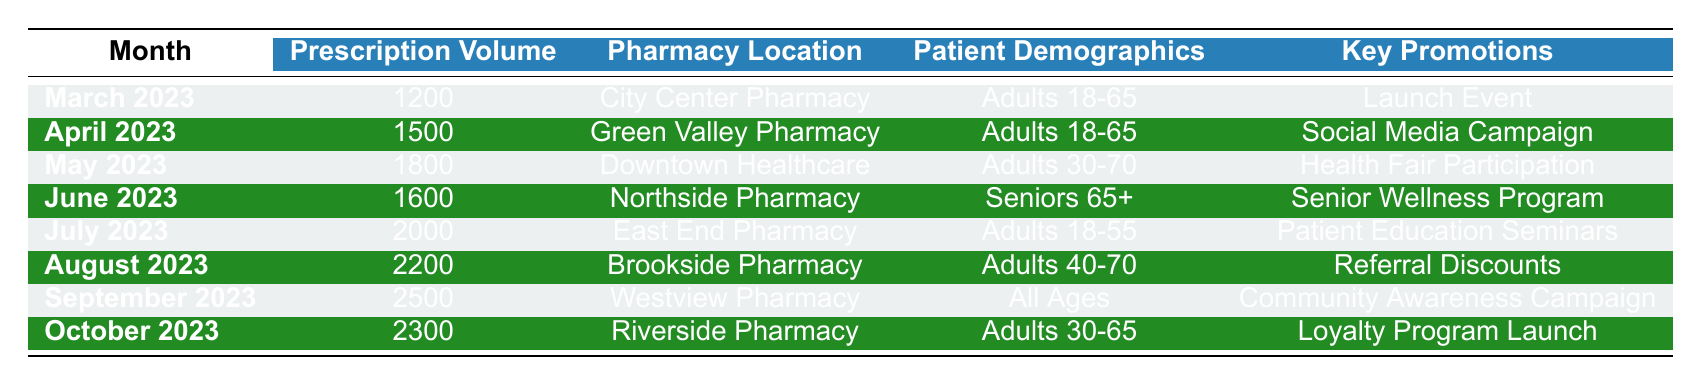What was the prescription volume in July 2023? The table shows that the prescription volume for July 2023 is listed as 2000.
Answer: 2000 Which month had the highest prescription volume? The months are compared, and the highest volume is 2500 for September 2023.
Answer: September 2023 What pharmacy had the lowest prescription volume and what was it? By examining the table, City Center Pharmacy in March 2023 had the lowest volume at 1200.
Answer: City Center Pharmacy, 1200 What is the average prescription volume over the six months listed? The total prescription volume from March to October is calculated as (1200 + 1500 + 1800 + 1600 + 2000 + 2200 + 2500 + 2300) = 12800. There are 8 months, so the average is 12800/8 = 1600.
Answer: 1600 Did any pharmacy have prescription volumes consistently increasing each month? The data shows that the prescription volumes generally increased over the months, but there was a decrease from September (2500) to October (2300), indicating no consistent increase.
Answer: No Which key promotion corresponds to the month with the highest prescription volume? The month with the highest volume is September 2023, corresponding to the "Community Awareness Campaign."
Answer: Community Awareness Campaign What patient demographic was targeted in the month with the second highest prescription volume? The second highest prescription volume of 2200 occurred in August 2023, targeting adults aged 40-70.
Answer: Adults 40-70 What was the total prescription volume for the months of March to June? The total prescription volume for March (1200), April (1500), May (1800), and June (1600) is calculated as (1200 + 1500 + 1800 + 1600) = 6100.
Answer: 6100 In which month did the pharmacy focus on a "Loyalty Program Launch"? The "Loyalty Program Launch" promotion took place in October 2023.
Answer: October 2023 Was the prescription volume higher in August or October? August had a volume of 2200 while October had 2300, so October had a higher volume.
Answer: October 